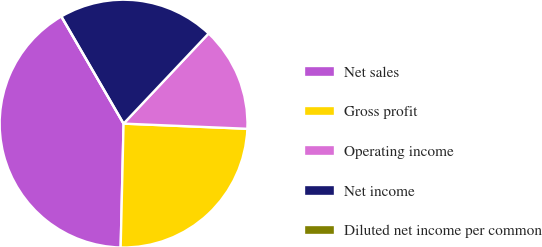Convert chart. <chart><loc_0><loc_0><loc_500><loc_500><pie_chart><fcel>Net sales<fcel>Gross profit<fcel>Operating income<fcel>Net income<fcel>Diluted net income per common<nl><fcel>41.26%<fcel>24.71%<fcel>13.63%<fcel>20.41%<fcel>0.0%<nl></chart> 